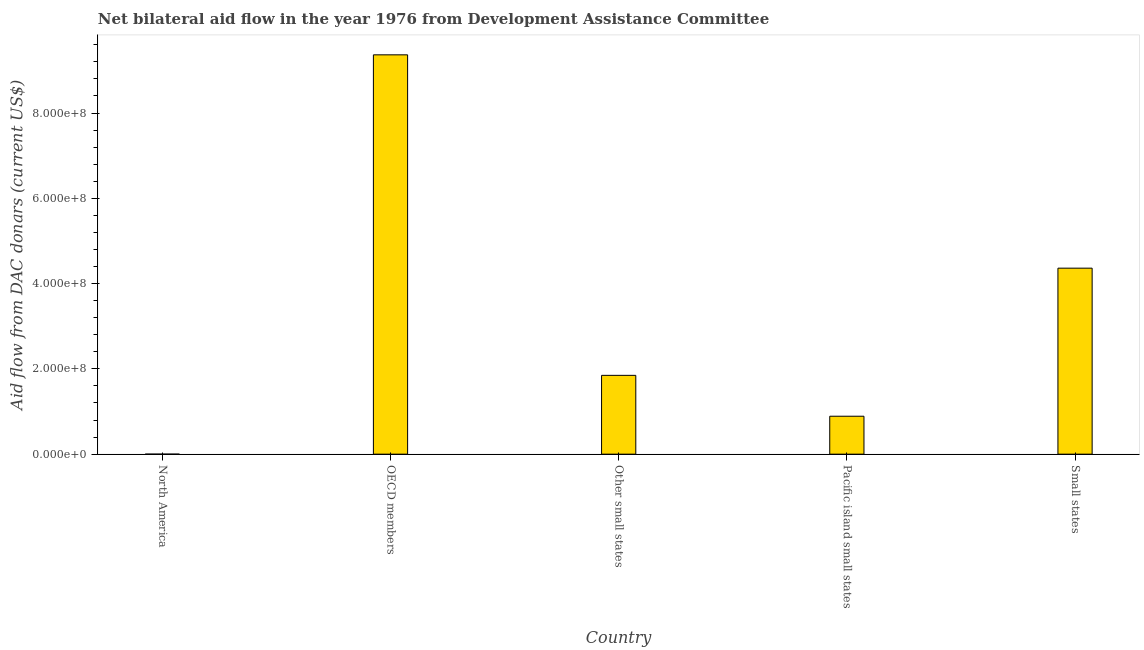Does the graph contain any zero values?
Keep it short and to the point. No. Does the graph contain grids?
Offer a very short reply. No. What is the title of the graph?
Keep it short and to the point. Net bilateral aid flow in the year 1976 from Development Assistance Committee. What is the label or title of the Y-axis?
Offer a terse response. Aid flow from DAC donars (current US$). What is the net bilateral aid flows from dac donors in OECD members?
Provide a short and direct response. 9.36e+08. Across all countries, what is the maximum net bilateral aid flows from dac donors?
Your response must be concise. 9.36e+08. In which country was the net bilateral aid flows from dac donors maximum?
Offer a very short reply. OECD members. What is the sum of the net bilateral aid flows from dac donors?
Your answer should be very brief. 1.65e+09. What is the difference between the net bilateral aid flows from dac donors in North America and OECD members?
Make the answer very short. -9.36e+08. What is the average net bilateral aid flows from dac donors per country?
Your response must be concise. 3.29e+08. What is the median net bilateral aid flows from dac donors?
Offer a very short reply. 1.85e+08. In how many countries, is the net bilateral aid flows from dac donors greater than 320000000 US$?
Make the answer very short. 2. Is the net bilateral aid flows from dac donors in North America less than that in OECD members?
Your answer should be compact. Yes. What is the difference between the highest and the second highest net bilateral aid flows from dac donors?
Give a very brief answer. 5.00e+08. Is the sum of the net bilateral aid flows from dac donors in Other small states and Small states greater than the maximum net bilateral aid flows from dac donors across all countries?
Offer a terse response. No. What is the difference between the highest and the lowest net bilateral aid flows from dac donors?
Provide a short and direct response. 9.36e+08. Are all the bars in the graph horizontal?
Provide a succinct answer. No. What is the difference between two consecutive major ticks on the Y-axis?
Provide a succinct answer. 2.00e+08. Are the values on the major ticks of Y-axis written in scientific E-notation?
Offer a terse response. Yes. What is the Aid flow from DAC donars (current US$) in North America?
Offer a terse response. 3.00e+04. What is the Aid flow from DAC donars (current US$) in OECD members?
Offer a terse response. 9.36e+08. What is the Aid flow from DAC donars (current US$) of Other small states?
Provide a succinct answer. 1.85e+08. What is the Aid flow from DAC donars (current US$) of Pacific island small states?
Your response must be concise. 8.90e+07. What is the Aid flow from DAC donars (current US$) of Small states?
Provide a succinct answer. 4.36e+08. What is the difference between the Aid flow from DAC donars (current US$) in North America and OECD members?
Make the answer very short. -9.36e+08. What is the difference between the Aid flow from DAC donars (current US$) in North America and Other small states?
Your answer should be very brief. -1.85e+08. What is the difference between the Aid flow from DAC donars (current US$) in North America and Pacific island small states?
Ensure brevity in your answer.  -8.90e+07. What is the difference between the Aid flow from DAC donars (current US$) in North America and Small states?
Make the answer very short. -4.36e+08. What is the difference between the Aid flow from DAC donars (current US$) in OECD members and Other small states?
Ensure brevity in your answer.  7.52e+08. What is the difference between the Aid flow from DAC donars (current US$) in OECD members and Pacific island small states?
Your response must be concise. 8.47e+08. What is the difference between the Aid flow from DAC donars (current US$) in OECD members and Small states?
Provide a succinct answer. 5.00e+08. What is the difference between the Aid flow from DAC donars (current US$) in Other small states and Pacific island small states?
Your answer should be very brief. 9.58e+07. What is the difference between the Aid flow from DAC donars (current US$) in Other small states and Small states?
Your answer should be compact. -2.51e+08. What is the difference between the Aid flow from DAC donars (current US$) in Pacific island small states and Small states?
Your answer should be compact. -3.47e+08. What is the ratio of the Aid flow from DAC donars (current US$) in North America to that in OECD members?
Provide a succinct answer. 0. What is the ratio of the Aid flow from DAC donars (current US$) in North America to that in Other small states?
Ensure brevity in your answer.  0. What is the ratio of the Aid flow from DAC donars (current US$) in OECD members to that in Other small states?
Provide a succinct answer. 5.07. What is the ratio of the Aid flow from DAC donars (current US$) in OECD members to that in Pacific island small states?
Make the answer very short. 10.52. What is the ratio of the Aid flow from DAC donars (current US$) in OECD members to that in Small states?
Make the answer very short. 2.15. What is the ratio of the Aid flow from DAC donars (current US$) in Other small states to that in Pacific island small states?
Make the answer very short. 2.08. What is the ratio of the Aid flow from DAC donars (current US$) in Other small states to that in Small states?
Make the answer very short. 0.42. What is the ratio of the Aid flow from DAC donars (current US$) in Pacific island small states to that in Small states?
Keep it short and to the point. 0.2. 